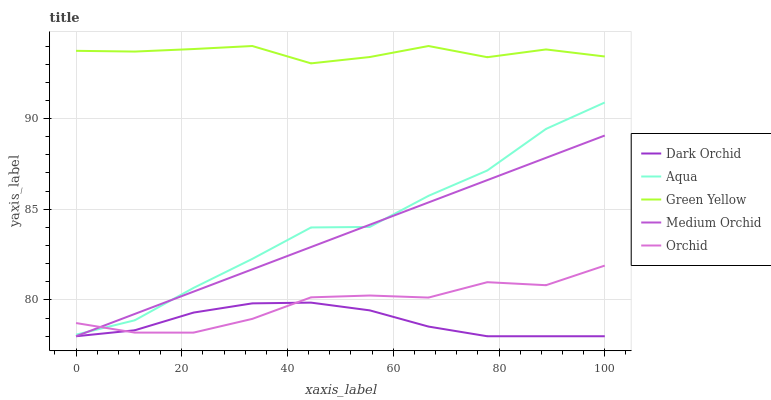Does Dark Orchid have the minimum area under the curve?
Answer yes or no. Yes. Does Green Yellow have the maximum area under the curve?
Answer yes or no. Yes. Does Aqua have the minimum area under the curve?
Answer yes or no. No. Does Aqua have the maximum area under the curve?
Answer yes or no. No. Is Medium Orchid the smoothest?
Answer yes or no. Yes. Is Aqua the roughest?
Answer yes or no. Yes. Is Green Yellow the smoothest?
Answer yes or no. No. Is Green Yellow the roughest?
Answer yes or no. No. Does Medium Orchid have the lowest value?
Answer yes or no. Yes. Does Aqua have the lowest value?
Answer yes or no. No. Does Green Yellow have the highest value?
Answer yes or no. Yes. Does Aqua have the highest value?
Answer yes or no. No. Is Aqua less than Green Yellow?
Answer yes or no. Yes. Is Green Yellow greater than Orchid?
Answer yes or no. Yes. Does Aqua intersect Orchid?
Answer yes or no. Yes. Is Aqua less than Orchid?
Answer yes or no. No. Is Aqua greater than Orchid?
Answer yes or no. No. Does Aqua intersect Green Yellow?
Answer yes or no. No. 